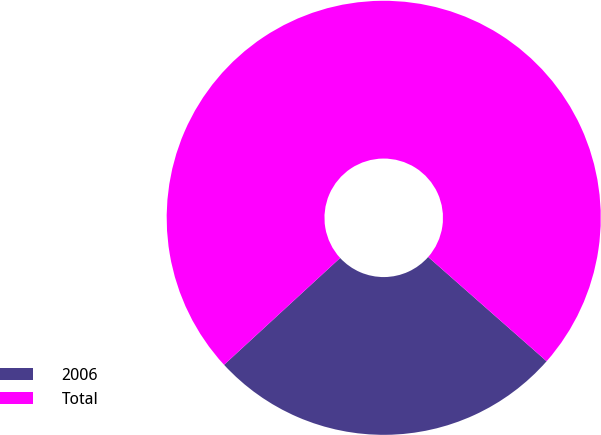Convert chart to OTSL. <chart><loc_0><loc_0><loc_500><loc_500><pie_chart><fcel>2006<fcel>Total<nl><fcel>26.67%<fcel>73.33%<nl></chart> 